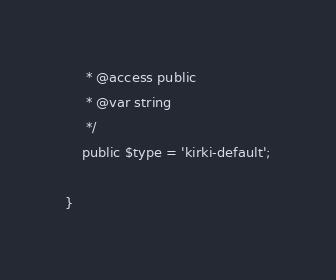Convert code to text. <code><loc_0><loc_0><loc_500><loc_500><_PHP_>	 * @access public
	 * @var string
	 */
	public $type = 'kirki-default';

}
</code> 